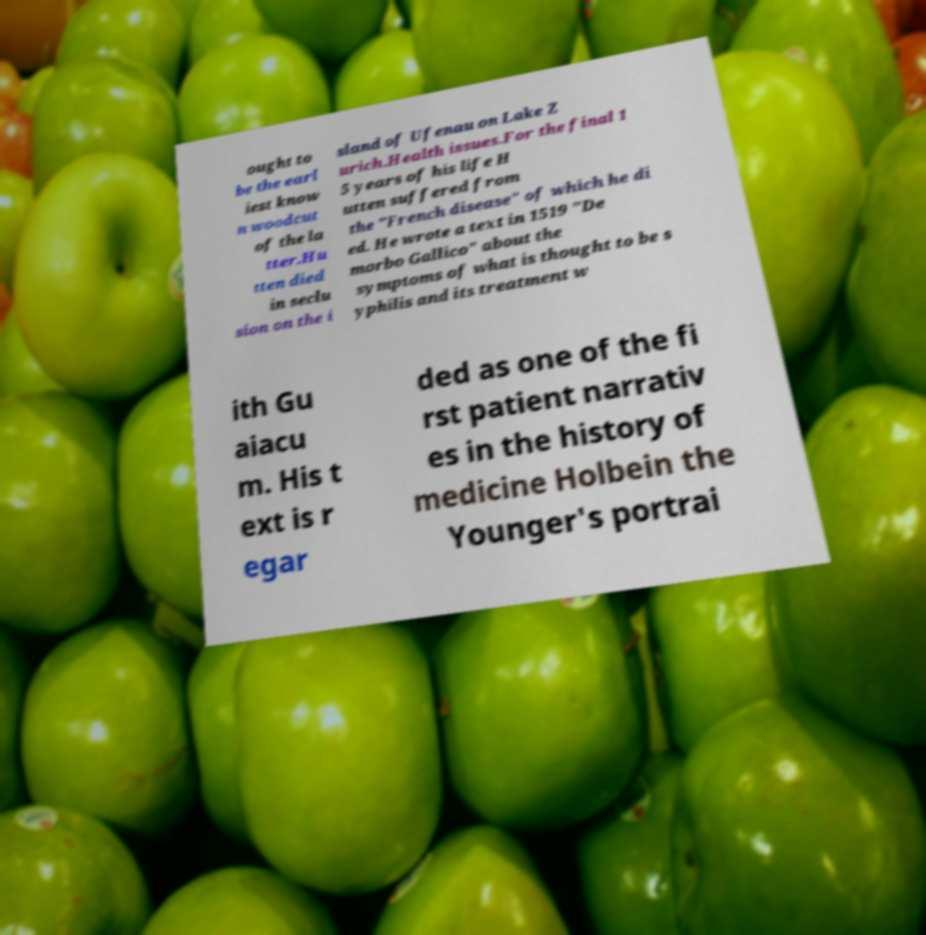Can you accurately transcribe the text from the provided image for me? ought to be the earl iest know n woodcut of the la tter.Hu tten died in seclu sion on the i sland of Ufenau on Lake Z urich.Health issues.For the final 1 5 years of his life H utten suffered from the "French disease" of which he di ed. He wrote a text in 1519 "De morbo Gallico" about the symptoms of what is thought to be s yphilis and its treatment w ith Gu aiacu m. His t ext is r egar ded as one of the fi rst patient narrativ es in the history of medicine Holbein the Younger's portrai 